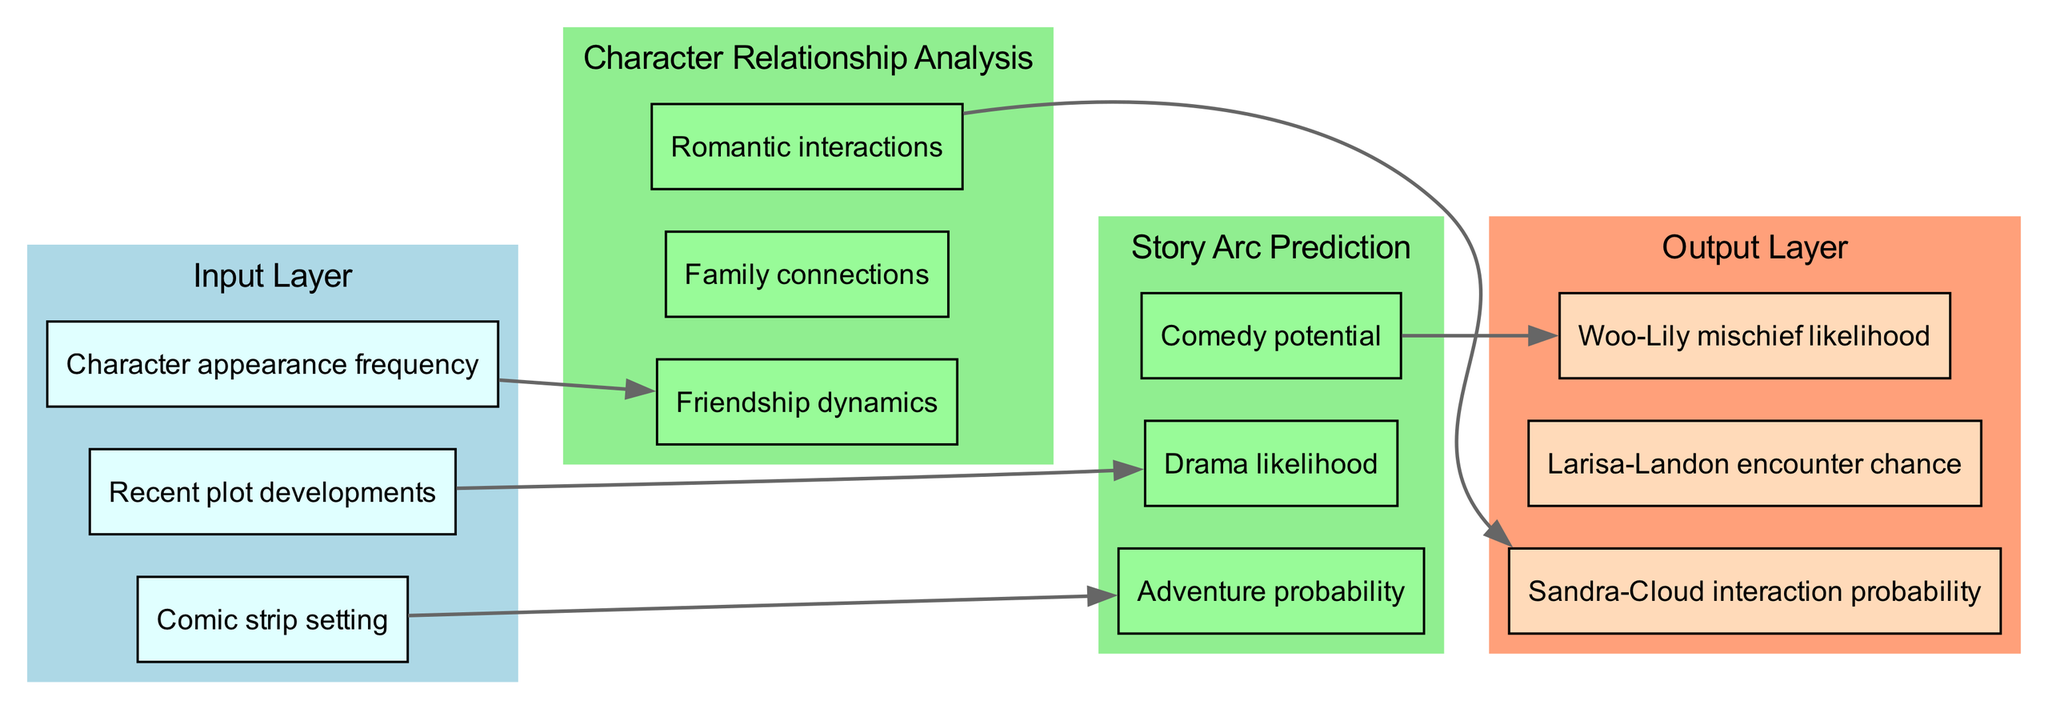What are the three nodes in the output layer? The output layer consists of three nodes identified as "Sandra-Cloud interaction probability," "Larisa-Landon encounter chance," and "Woo-Lily mischief likelihood." These are visible when examining the output layer of the diagram.
Answer: Sandra-Cloud interaction probability, Larisa-Landon encounter chance, Woo-Lily mischief likelihood How many nodes are in the input layer? There are three nodes listed in the input layer, which include "Character appearance frequency," "Comic strip setting," and "Recent plot developments." This can be counted directly from the input layer in the diagram.
Answer: 3 What is one of the hidden layer names? The hidden layers are named "Character Relationship Analysis" and "Story Arc Prediction." Either of these can be identified when looking at the section for hidden layers in the diagram.
Answer: Character Relationship Analysis What is connected to "Drama likelihood"? "Recent plot developments" has a direct connection to "Drama likelihood," based on how the edges are represented in the diagram. By tracing the arrows, one can see this connection clearly.
Answer: Recent plot developments Which node in the output layer is influenced by "Comedy potential"? "Woo-Lily mischief likelihood" is the output node influenced by "Comedy potential," as indicated by the directed edges in the diagram that show the flow of information from one node to the other.
Answer: Woo-Lily mischief likelihood How many connections are between the input layer and the first hidden layer? There are three connections from the input layer to the first hidden layer, corresponding to each input node's impact on the dynamics analyzed in the hidden layers. This can be verified by examining the connections listed in the diagram.
Answer: 3 Which nodes are part of the hidden layer "Character Relationship Analysis"? The nodes included in the "Character Relationship Analysis" hidden layer are "Friendship dynamics," "Romantic interactions," and "Family connections." These nodes are visually grouped under this layer in the diagram.
Answer: Friendship dynamics, Romantic interactions, Family connections What type of interaction does "Woo-Lily mischief likelihood" relate to? "Woo-Lily mischief likelihood" is associated with the comedic elements of the narrative, as indicated by its connection to "Comedy potential." This can be deduced by following the edges from the hidden layer to the output layer in the diagram.
Answer: Comedy 